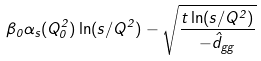<formula> <loc_0><loc_0><loc_500><loc_500>\beta _ { 0 } \alpha _ { s } ( Q _ { 0 } ^ { 2 } ) \ln ( s / Q ^ { 2 } ) - \sqrt { \frac { t \ln ( s / Q ^ { 2 } ) } { - \hat { d } _ { g g } } }</formula> 